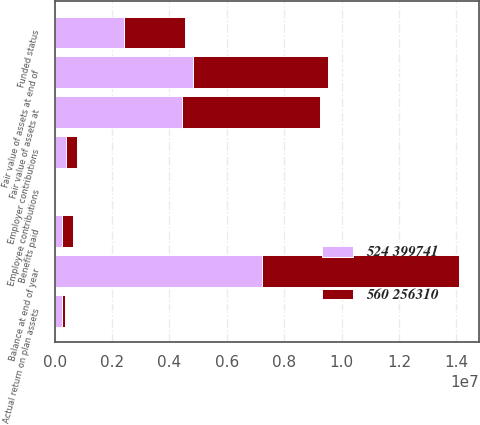Convert chart. <chart><loc_0><loc_0><loc_500><loc_500><stacked_bar_chart><ecel><fcel>Balance at end of year<fcel>Fair value of assets at<fcel>Actual return on plan assets<fcel>Employer contributions<fcel>Employee contributions<fcel>Benefits paid<fcel>Fair value of assets at end of<fcel>Funded status<nl><fcel>560 256310<fcel>6.84824e+06<fcel>4.82797e+06<fcel>117130<fcel>395814<fcel>524<fcel>399741<fcel>4.70743e+06<fcel>2.1408e+06<nl><fcel>524 399741<fcel>7.23054e+06<fcel>4.42924e+06<fcel>255599<fcel>398880<fcel>560<fcel>256310<fcel>4.82797e+06<fcel>2.40258e+06<nl></chart> 